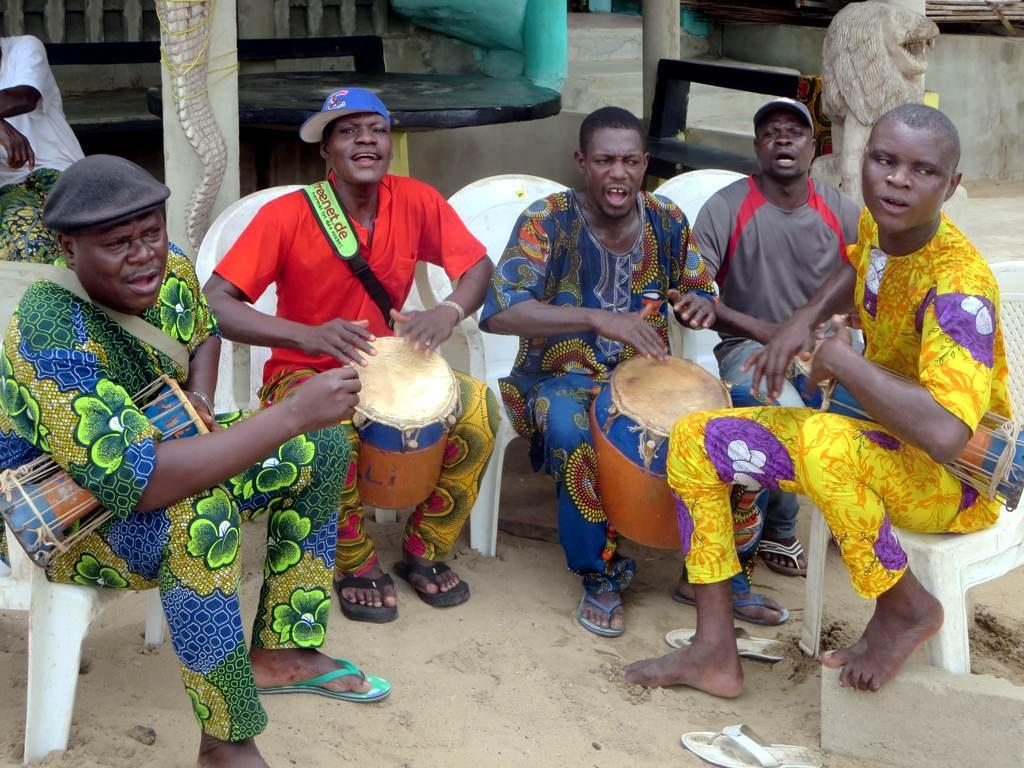What are the people in the image doing? The people are sitting on chairs and playing drums. What can be seen in the background of the image? There are statues, pillars, a table, a person, and a wall visible in the background. What type of surface is visible in the image? There is sand visible in the image. Are the fairies in the image playing the drums quietly? There are no fairies present in the image, and therefore they cannot be playing the drums. 